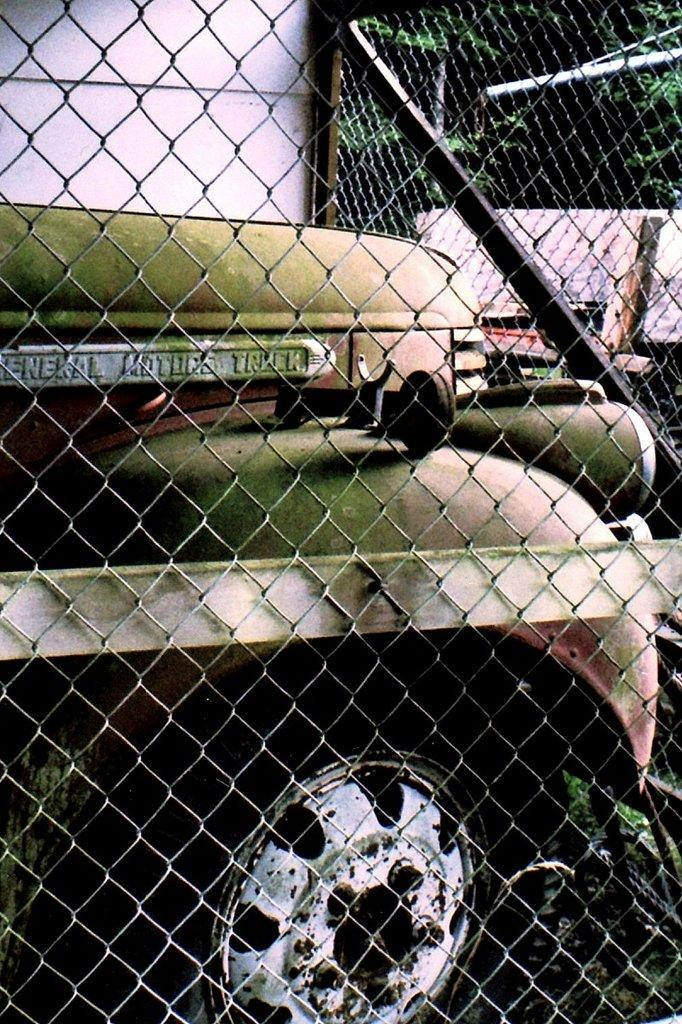What type of vehicle is in the image? There is a motor vehicle in the image. Can you describe the vehicle's surroundings? The motor vehicle is inside a mesh. What type of natural environment is visible in the image? There are trees visible in the image. What type of furniture is being used by the mother in the image? There is no furniture or mother present in the image; it only features a motor vehicle inside a mesh with trees visible in the background. 